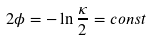Convert formula to latex. <formula><loc_0><loc_0><loc_500><loc_500>2 \phi = - \ln \frac { \kappa } { 2 } = c o n s t</formula> 